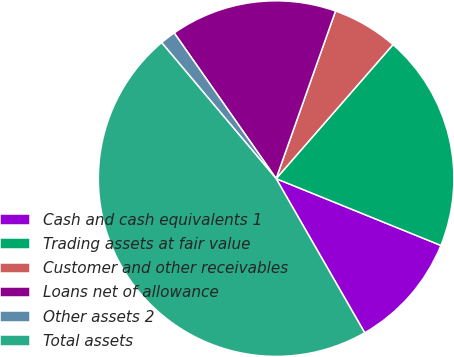Convert chart to OTSL. <chart><loc_0><loc_0><loc_500><loc_500><pie_chart><fcel>Cash and cash equivalents 1<fcel>Trading assets at fair value<fcel>Customer and other receivables<fcel>Loans net of allowance<fcel>Other assets 2<fcel>Total assets<nl><fcel>10.57%<fcel>19.72%<fcel>5.99%<fcel>15.14%<fcel>1.42%<fcel>47.16%<nl></chart> 